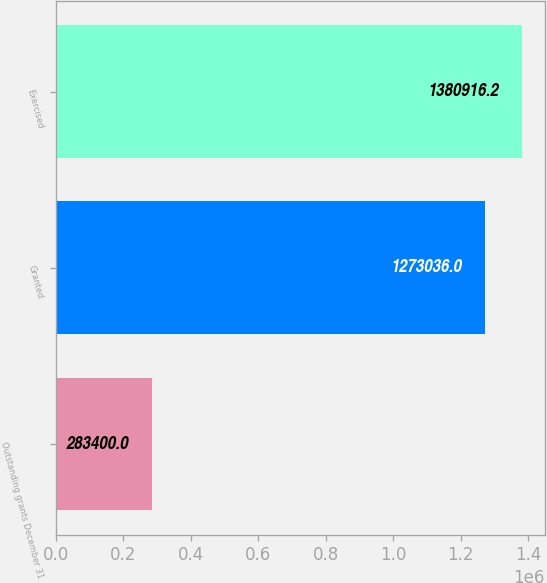Convert chart to OTSL. <chart><loc_0><loc_0><loc_500><loc_500><bar_chart><fcel>Outstanding grants December 31<fcel>Granted<fcel>Exercised<nl><fcel>283400<fcel>1.27304e+06<fcel>1.38092e+06<nl></chart> 